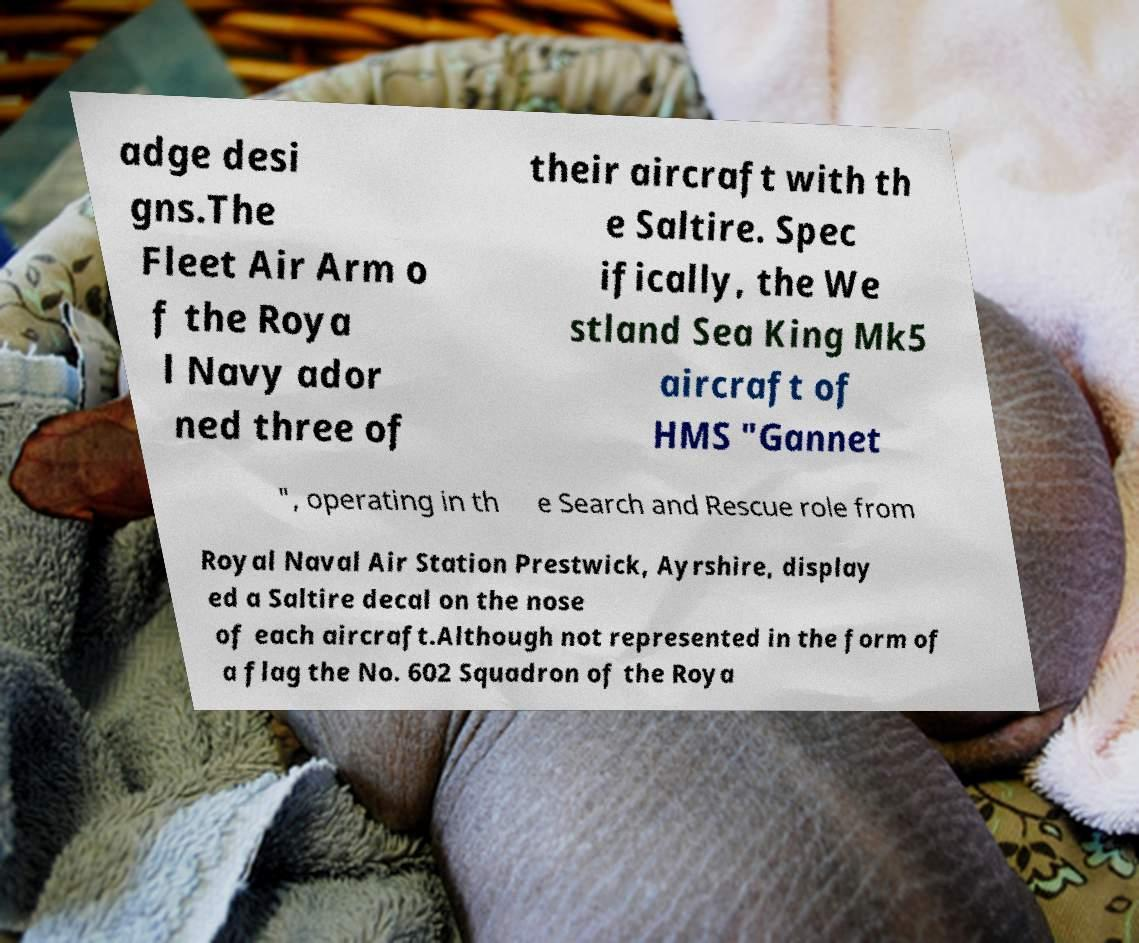Could you assist in decoding the text presented in this image and type it out clearly? adge desi gns.The Fleet Air Arm o f the Roya l Navy ador ned three of their aircraft with th e Saltire. Spec ifically, the We stland Sea King Mk5 aircraft of HMS "Gannet ", operating in th e Search and Rescue role from Royal Naval Air Station Prestwick, Ayrshire, display ed a Saltire decal on the nose of each aircraft.Although not represented in the form of a flag the No. 602 Squadron of the Roya 